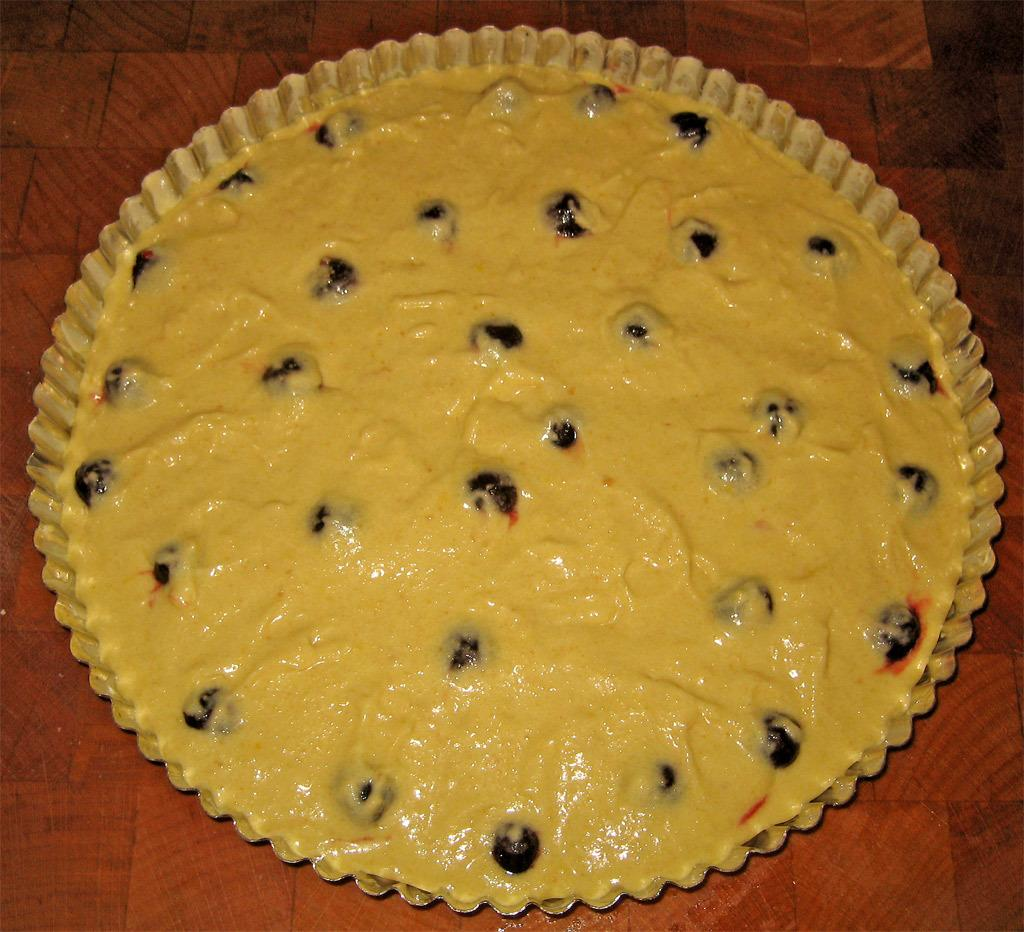What is the main subject of the image? There is a cake in the image. How is the cake presented? The cake is in a bowl. What is the color of the cake? The cake is yellow in color. What type of fruits are in the cake? There are black color fruits in the cake. Where is the cake located? The cake is placed on a table. How many lizards can be seen crawling on the cake in the image? There are no lizards present in the image, so it is not possible to determine how many might be crawling on the cake. 